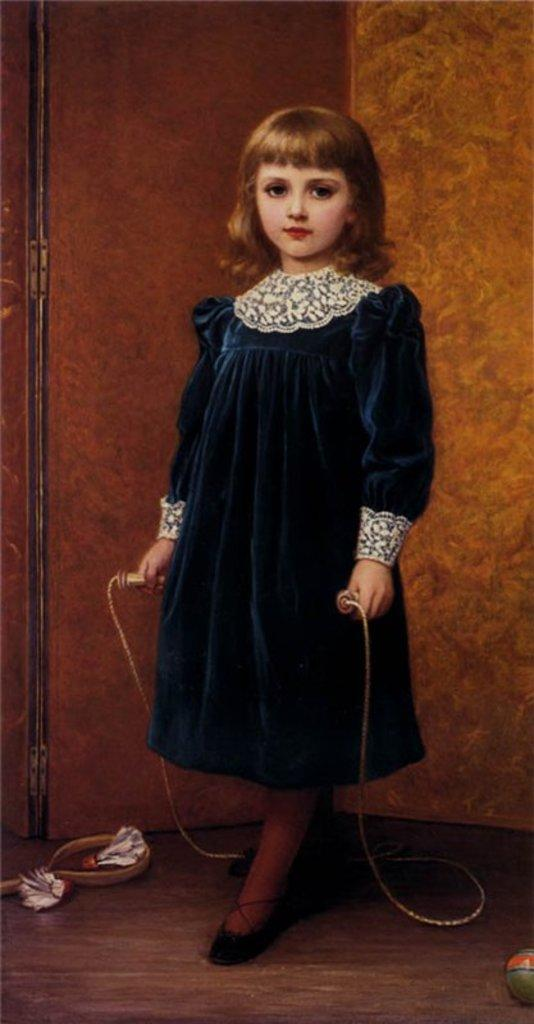Who is the main subject in the image? There is a small girl in the image. What is the girl holding in the image? The girl is holding a rope. What objects can be seen on the floor in the foreground? There is a ribbon and a ball on the floor in the foreground. What is the degree of the alarm in the image? There is no alarm present in the image, so it is not possible to determine its degree. 